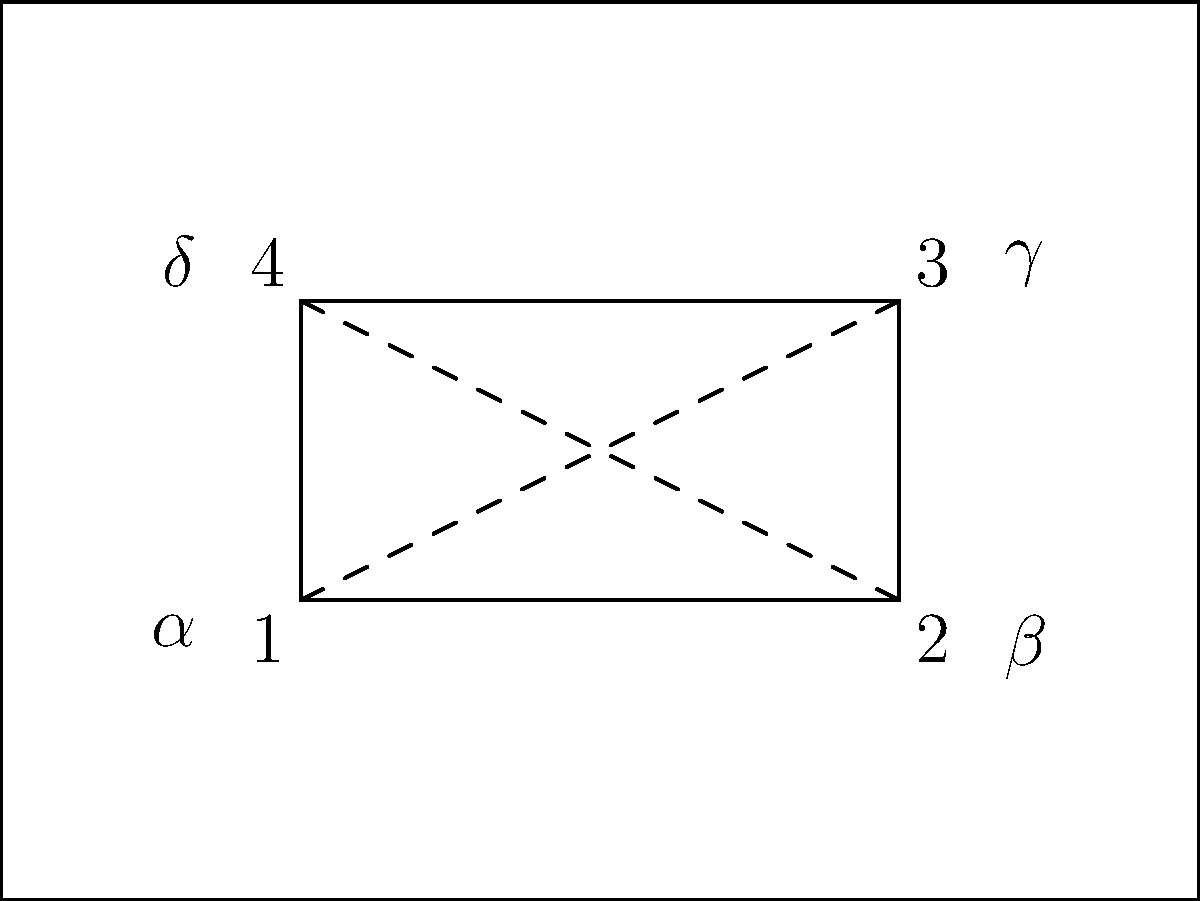In your latest geometric print fabric design, you've incorporated a pattern of intersecting diagonal lines forming a rectangle within a larger rectangle, as shown in the diagram. If angles $\alpha$ and $\gamma$ are congruent, which other pair of angles must also be congruent for the inner rectangle to maintain its shape? Let's approach this step-by-step:

1) In a rectangle, opposite angles are always congruent. This applies to both the inner and outer rectangles in the design.

2) We're given that angles $\alpha$ and $\gamma$ are congruent. These are alternate angles formed by the diagonal line EG intersecting parallel lines EF and HG.

3) When a transversal (like EG) intersects two parallel lines, corresponding angles are congruent. This means $\alpha \cong \gamma$ and $\beta \cong \delta$.

4) For the inner shape EFGH to be a rectangle, we need to ensure that its opposite angles are congruent and all angles are right angles.

5) We already know that $\alpha \cong \gamma$. For EFGH to be a rectangle, we must also have $\beta \cong \delta$.

6) This pair of congruent angles ($\beta$ and $\delta$) ensures that the other two opposite angles of the inner rectangle are also congruent, maintaining its rectangular shape.

Therefore, for the inner rectangle to maintain its shape given that $\alpha \cong \gamma$, angles $\beta$ and $\delta$ must be congruent.
Answer: $\beta$ and $\delta$ 